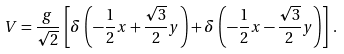Convert formula to latex. <formula><loc_0><loc_0><loc_500><loc_500>V = \frac { g } { \sqrt { 2 } } \, \left [ \delta \, \left ( - \frac { 1 } { 2 } x + \frac { \sqrt { 3 } } { 2 } y \right ) + \delta \, \left ( - \frac { 1 } { 2 } x - \frac { \sqrt { 3 } } { 2 } y \right ) \right ] \, .</formula> 